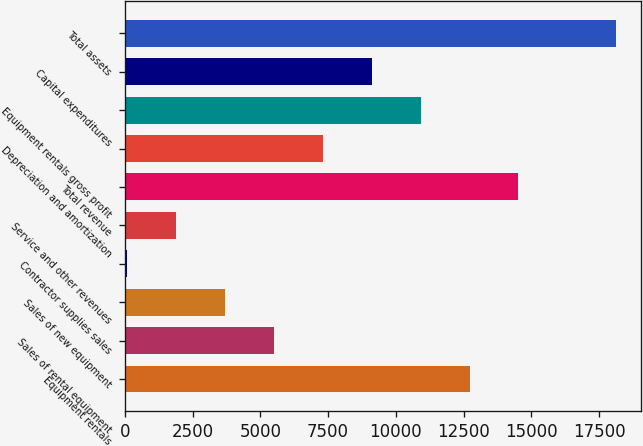<chart> <loc_0><loc_0><loc_500><loc_500><bar_chart><fcel>Equipment rentals<fcel>Sales of rental equipment<fcel>Sales of new equipment<fcel>Contractor supplies sales<fcel>Service and other revenues<fcel>Total revenue<fcel>Depreciation and amortization<fcel>Equipment rentals gross profit<fcel>Capital expenditures<fcel>Total assets<nl><fcel>12720.4<fcel>5503.6<fcel>3699.4<fcel>91<fcel>1895.2<fcel>14524.6<fcel>7307.8<fcel>10916.2<fcel>9112<fcel>18133<nl></chart> 